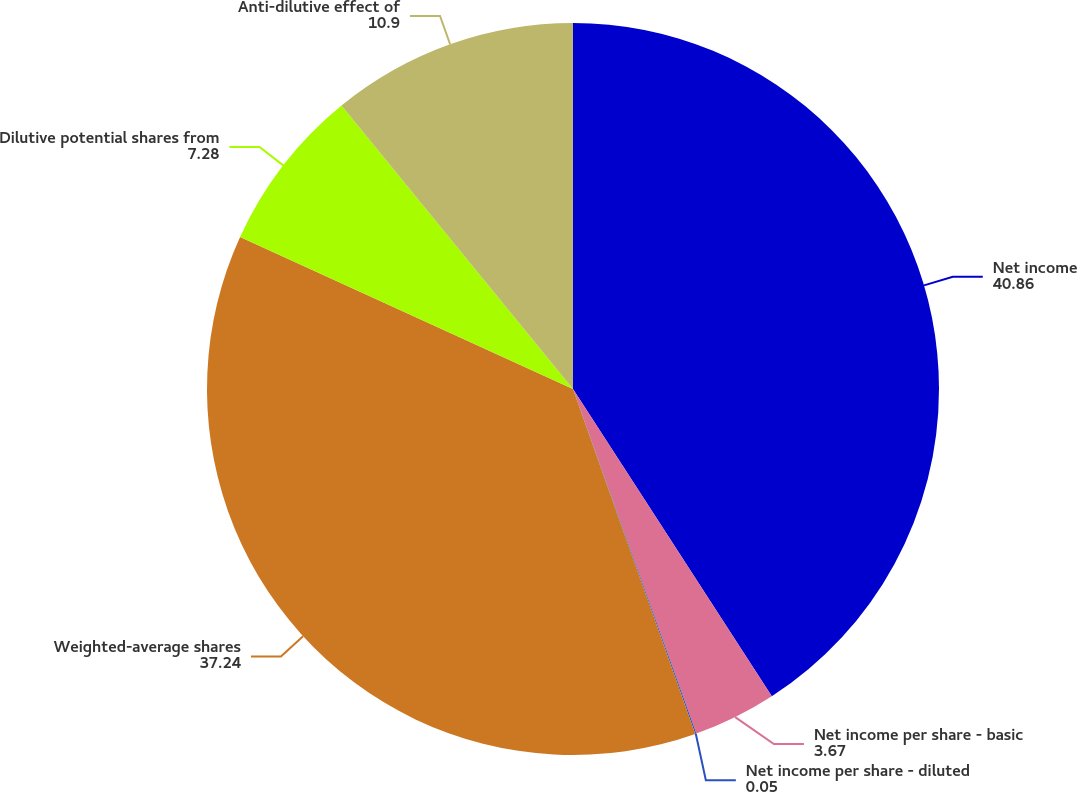<chart> <loc_0><loc_0><loc_500><loc_500><pie_chart><fcel>Net income<fcel>Net income per share - basic<fcel>Net income per share - diluted<fcel>Weighted-average shares<fcel>Dilutive potential shares from<fcel>Anti-dilutive effect of<nl><fcel>40.86%<fcel>3.67%<fcel>0.05%<fcel>37.24%<fcel>7.28%<fcel>10.9%<nl></chart> 